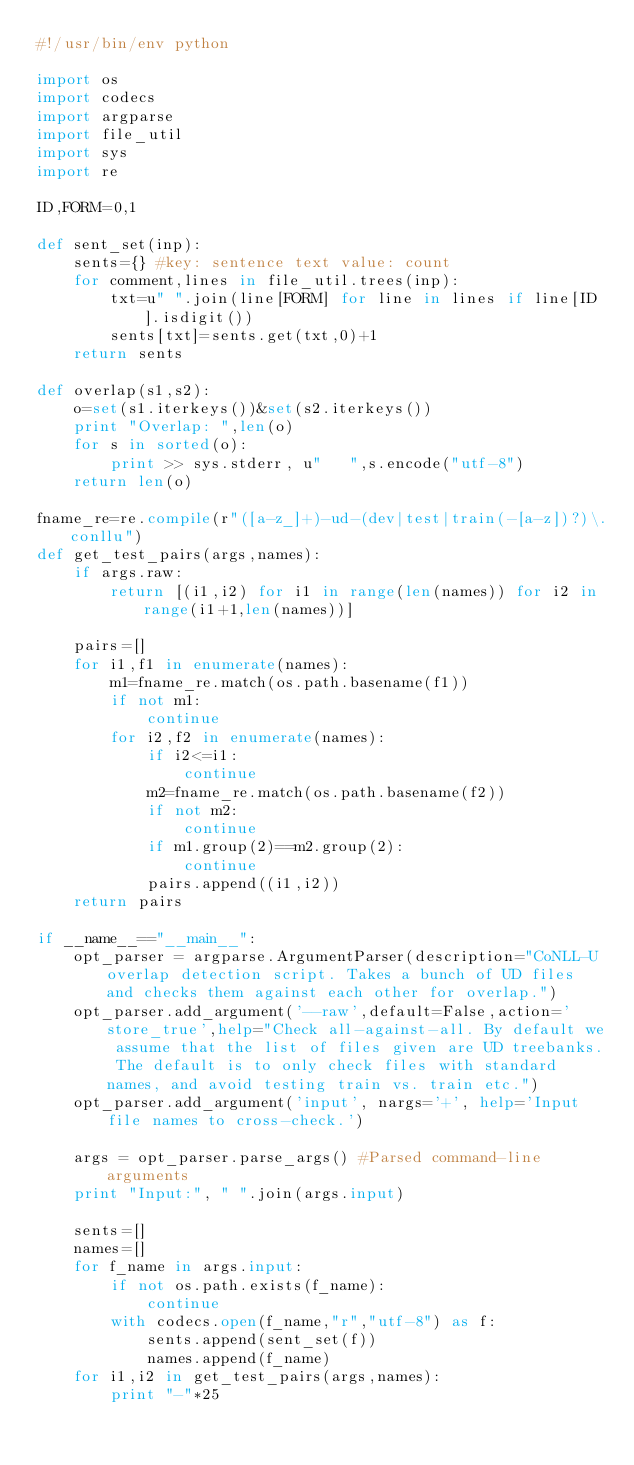Convert code to text. <code><loc_0><loc_0><loc_500><loc_500><_Python_>#!/usr/bin/env python

import os
import codecs
import argparse
import file_util
import sys
import re

ID,FORM=0,1

def sent_set(inp):
    sents={} #key: sentence text value: count
    for comment,lines in file_util.trees(inp):
        txt=u" ".join(line[FORM] for line in lines if line[ID].isdigit())
        sents[txt]=sents.get(txt,0)+1
    return sents

def overlap(s1,s2):
    o=set(s1.iterkeys())&set(s2.iterkeys())
    print "Overlap: ",len(o)
    for s in sorted(o):
        print >> sys.stderr, u"   ",s.encode("utf-8")
    return len(o)

fname_re=re.compile(r"([a-z_]+)-ud-(dev|test|train(-[a-z])?)\.conllu")
def get_test_pairs(args,names):
    if args.raw:
        return [(i1,i2) for i1 in range(len(names)) for i2 in range(i1+1,len(names))]

    pairs=[]
    for i1,f1 in enumerate(names):
        m1=fname_re.match(os.path.basename(f1))
        if not m1:
            continue
        for i2,f2 in enumerate(names):
            if i2<=i1:
                continue
            m2=fname_re.match(os.path.basename(f2))
            if not m2:
                continue
            if m1.group(2)==m2.group(2):
                continue
            pairs.append((i1,i2))
    return pairs

if __name__=="__main__":
    opt_parser = argparse.ArgumentParser(description="CoNLL-U overlap detection script. Takes a bunch of UD files and checks them against each other for overlap.")
    opt_parser.add_argument('--raw',default=False,action='store_true',help="Check all-against-all. By default we assume that the list of files given are UD treebanks. The default is to only check files with standard names, and avoid testing train vs. train etc.")
    opt_parser.add_argument('input', nargs='+', help='Input file names to cross-check.')
    
    args = opt_parser.parse_args() #Parsed command-line arguments
    print "Input:", " ".join(args.input)
    
    sents=[] 
    names=[]
    for f_name in args.input:
        if not os.path.exists(f_name):
            continue
        with codecs.open(f_name,"r","utf-8") as f:
            sents.append(sent_set(f))
            names.append(f_name)
    for i1,i2 in get_test_pairs(args,names):
        print "-"*25</code> 